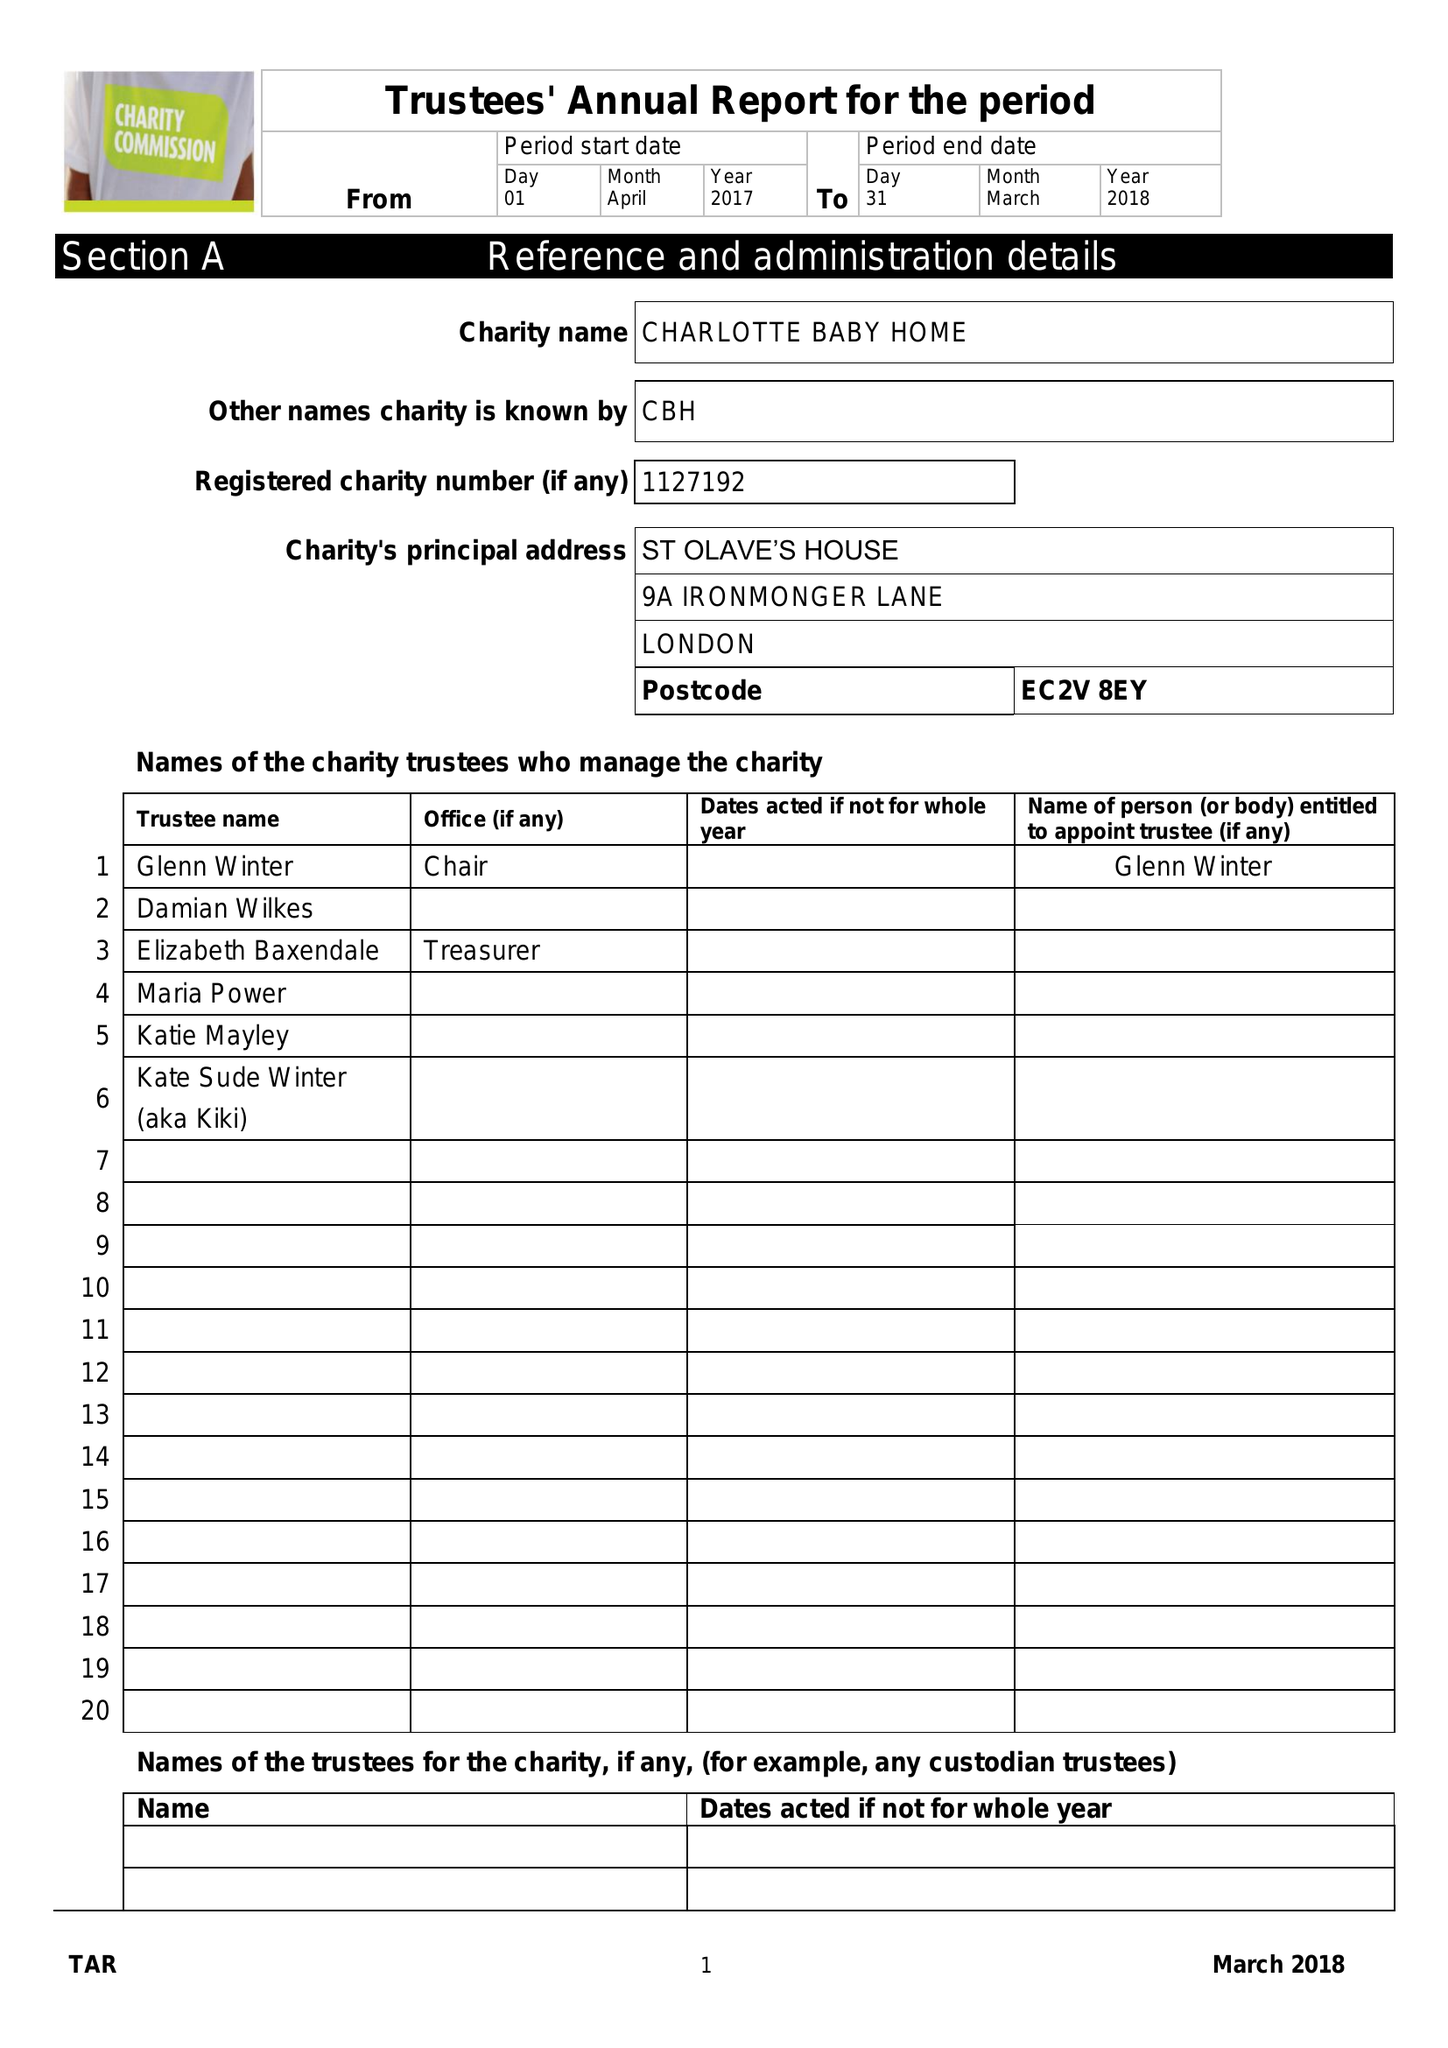What is the value for the charity_number?
Answer the question using a single word or phrase. 1127192 